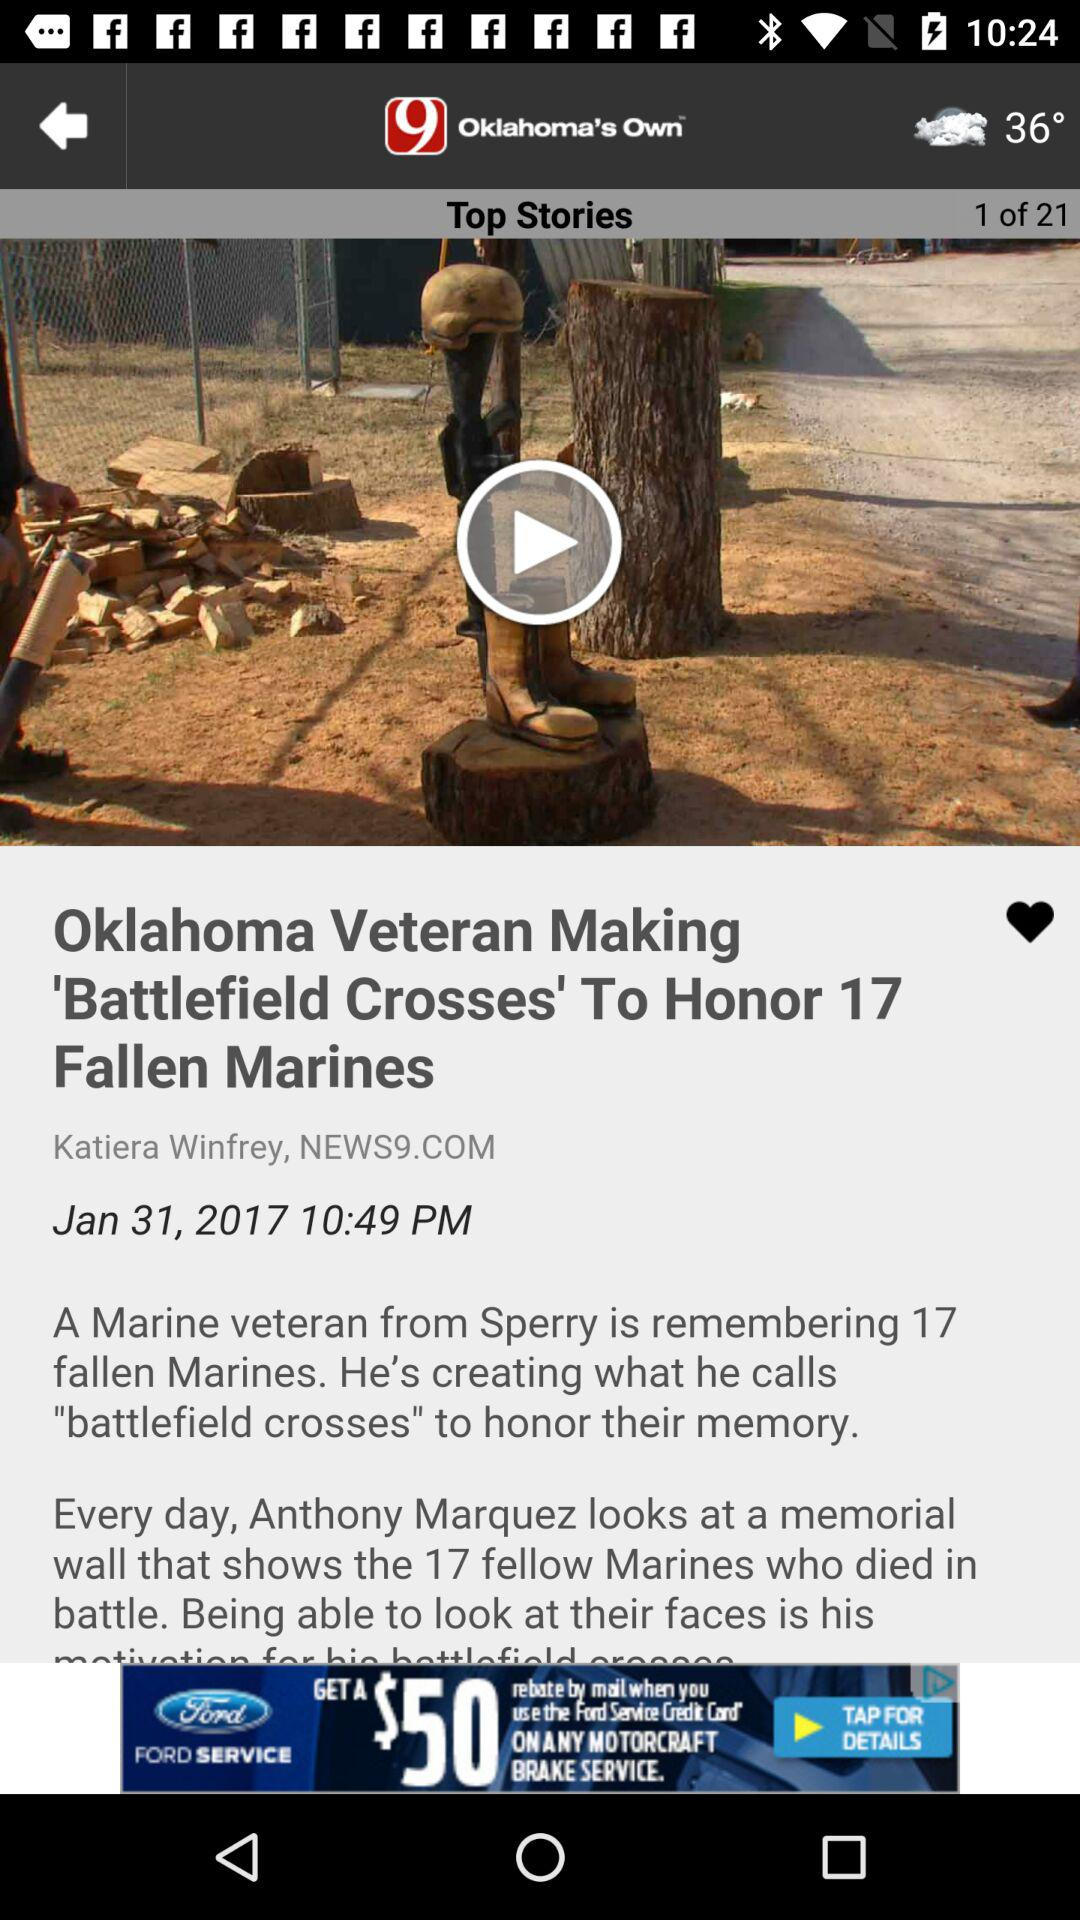How many top stories are there? There are 21 top stories. 